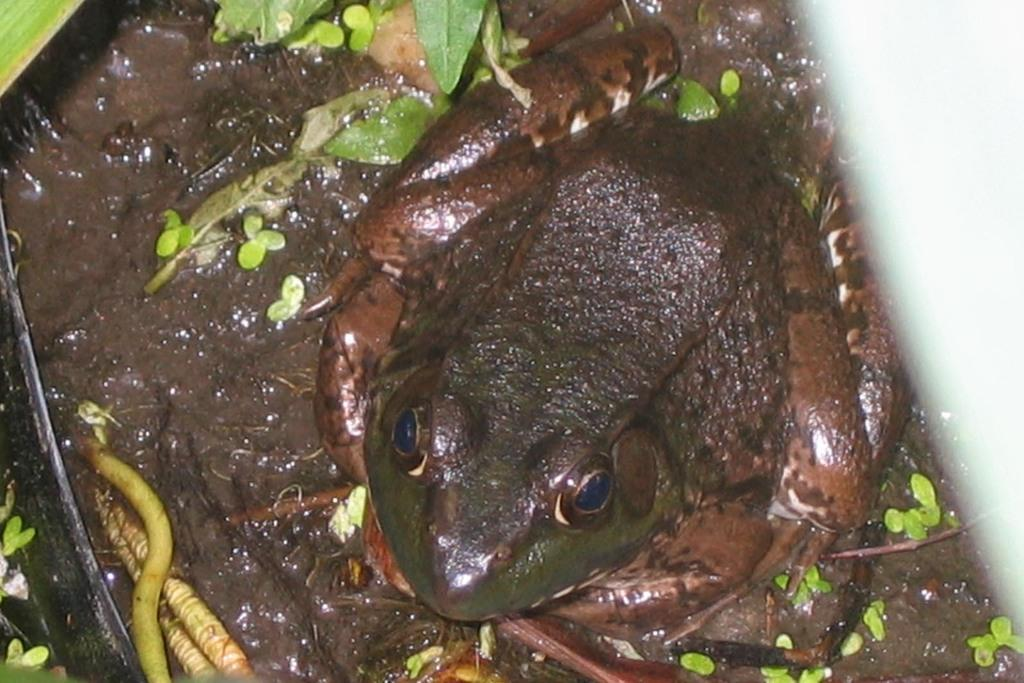What type of animal is in the image? There is a frog in the image. Are there any other animals present in the image? Yes, there are animals in the image. What is the surface on which the animals are located? The animals are on the mud. What type of vegetation can be seen in the image? There are plants in the image. What rule does the frog follow in the image? There is no rule mentioned or depicted in the image, as it is a simple image of a frog and other animals on mud with plants. 